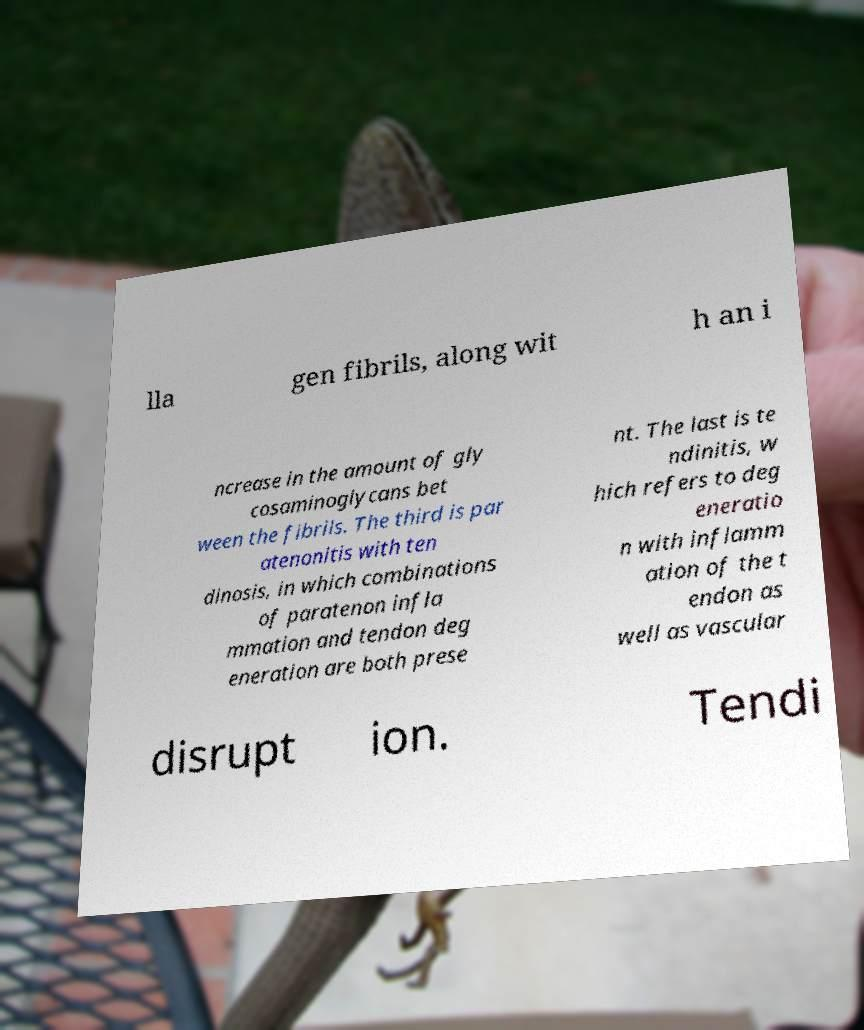For documentation purposes, I need the text within this image transcribed. Could you provide that? lla gen fibrils, along wit h an i ncrease in the amount of gly cosaminoglycans bet ween the fibrils. The third is par atenonitis with ten dinosis, in which combinations of paratenon infla mmation and tendon deg eneration are both prese nt. The last is te ndinitis, w hich refers to deg eneratio n with inflamm ation of the t endon as well as vascular disrupt ion. Tendi 